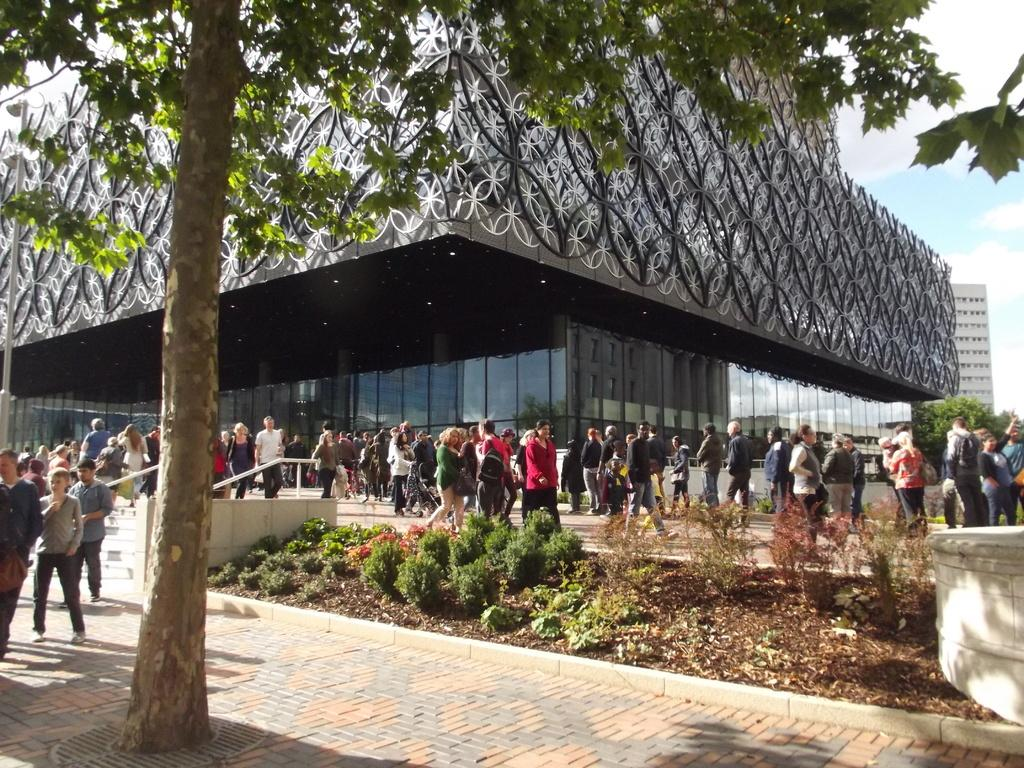What is the main object in the foreground of the image? There is a tree in the image. What can be seen happening in the background? People are walking on a path in the background. What type of structures are visible in the distance? There are buildings visible in the background. What type of vegetation is present between the tree and the people? Small plants are present between the tree and the people. What color are the trousers worn by the desk in the image? There is no desk present in the image, and therefore no trousers to describe. 